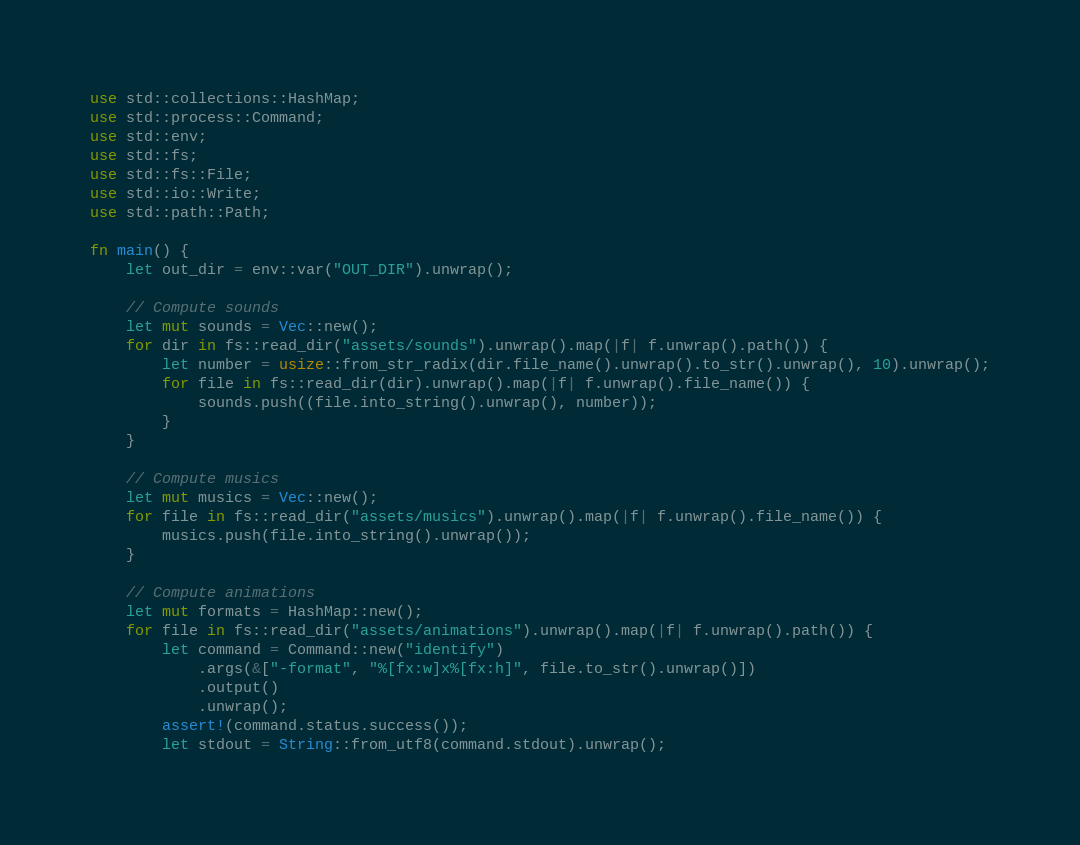Convert code to text. <code><loc_0><loc_0><loc_500><loc_500><_Rust_>use std::collections::HashMap;
use std::process::Command;
use std::env;
use std::fs;
use std::fs::File;
use std::io::Write;
use std::path::Path;

fn main() {
    let out_dir = env::var("OUT_DIR").unwrap();

    // Compute sounds
    let mut sounds = Vec::new();
    for dir in fs::read_dir("assets/sounds").unwrap().map(|f| f.unwrap().path()) {
        let number = usize::from_str_radix(dir.file_name().unwrap().to_str().unwrap(), 10).unwrap();
        for file in fs::read_dir(dir).unwrap().map(|f| f.unwrap().file_name()) {
            sounds.push((file.into_string().unwrap(), number));
        }
    }

    // Compute musics
    let mut musics = Vec::new();
    for file in fs::read_dir("assets/musics").unwrap().map(|f| f.unwrap().file_name()) {
        musics.push(file.into_string().unwrap());
    }

    // Compute animations
    let mut formats = HashMap::new();
    for file in fs::read_dir("assets/animations").unwrap().map(|f| f.unwrap().path()) {
        let command = Command::new("identify")
            .args(&["-format", "%[fx:w]x%[fx:h]", file.to_str().unwrap()])
            .output()
            .unwrap();
        assert!(command.status.success());
        let stdout = String::from_utf8(command.stdout).unwrap();</code> 